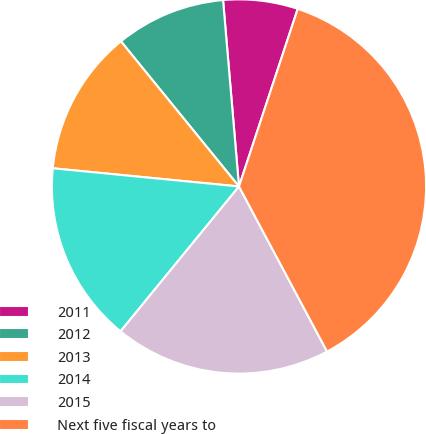Convert chart. <chart><loc_0><loc_0><loc_500><loc_500><pie_chart><fcel>2011<fcel>2012<fcel>2013<fcel>2014<fcel>2015<fcel>Next five fiscal years to<nl><fcel>6.44%<fcel>9.51%<fcel>12.58%<fcel>15.64%<fcel>18.71%<fcel>37.11%<nl></chart> 